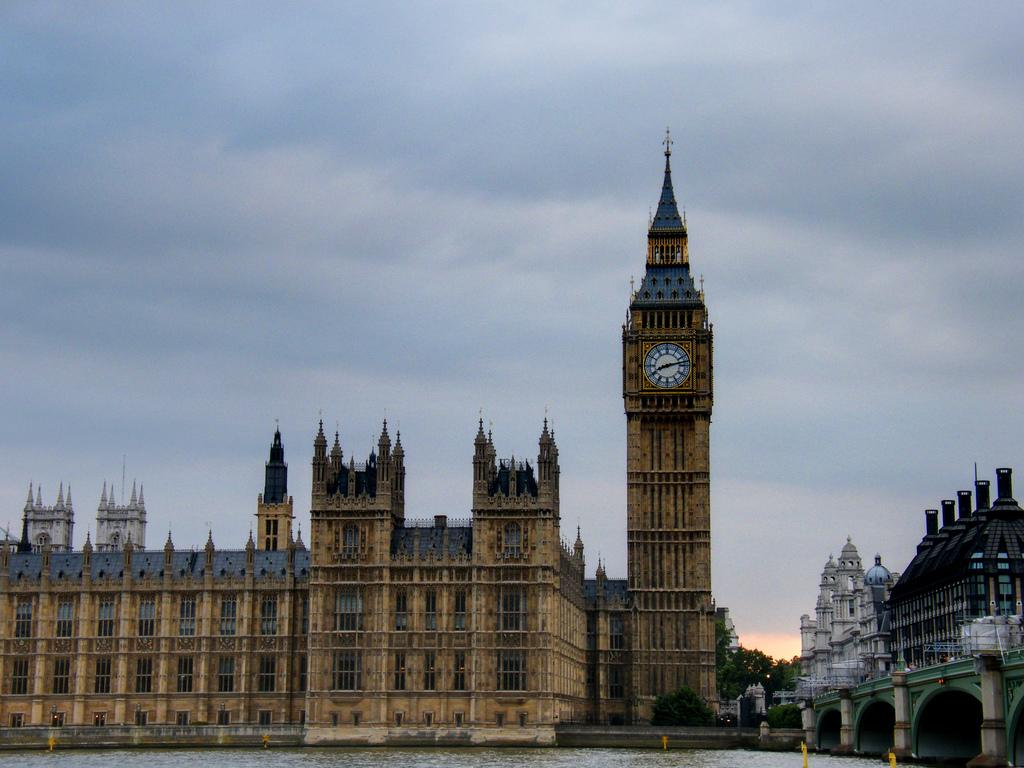What is present at the bottom of the image? There is water at the bottom of the image. What can be seen in the middle of the image? There are buildings and trees in the middle of the image. What is visible at the top of the image? The sky is visible at the top of the image. What type of structure is present in the image? There is a clock tower in the image. Where are the scissors located in the image? There are no scissors present in the image. What type of board is visible in the image? There is no board present in the image. 